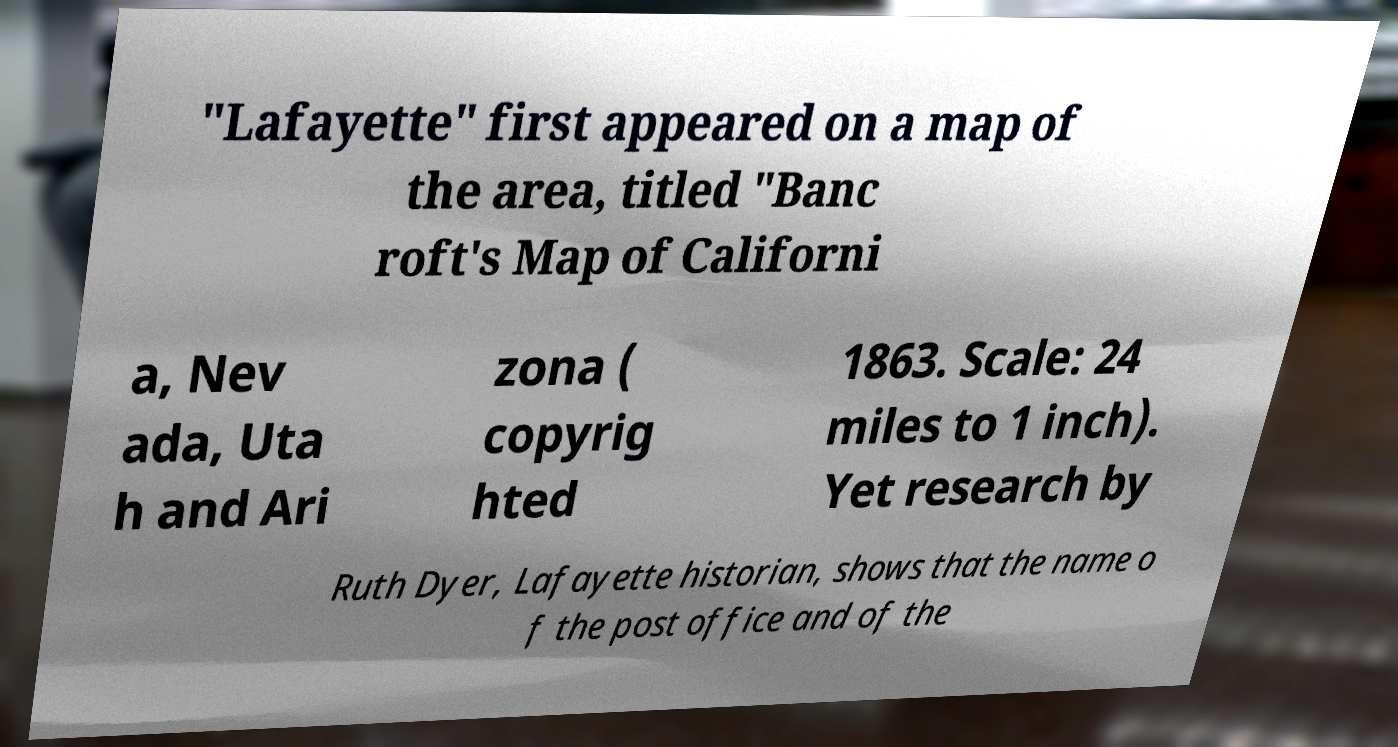There's text embedded in this image that I need extracted. Can you transcribe it verbatim? "Lafayette" first appeared on a map of the area, titled "Banc roft's Map of Californi a, Nev ada, Uta h and Ari zona ( copyrig hted 1863. Scale: 24 miles to 1 inch). Yet research by Ruth Dyer, Lafayette historian, shows that the name o f the post office and of the 